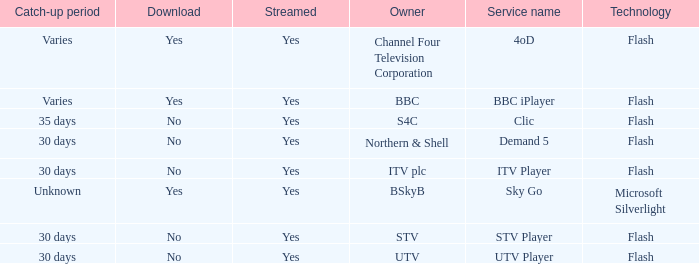What Service Name has UTV as the owner? UTV Player. 